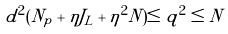<formula> <loc_0><loc_0><loc_500><loc_500>d ^ { 2 } ( N _ { p } + \eta J _ { L } + \eta ^ { 2 } N ) \leq q ^ { 2 } \leq N</formula> 